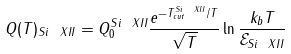<formula> <loc_0><loc_0><loc_500><loc_500>Q ( T ) _ { S i \ X I I } = Q _ { 0 } ^ { S i \ X I I } \frac { e ^ { - T _ { c u t } ^ { S i \ X I I } / T } } { \sqrt { T } } \ln { \frac { k _ { b } T } { \mathcal { E } _ { S i \ X I I } } }</formula> 